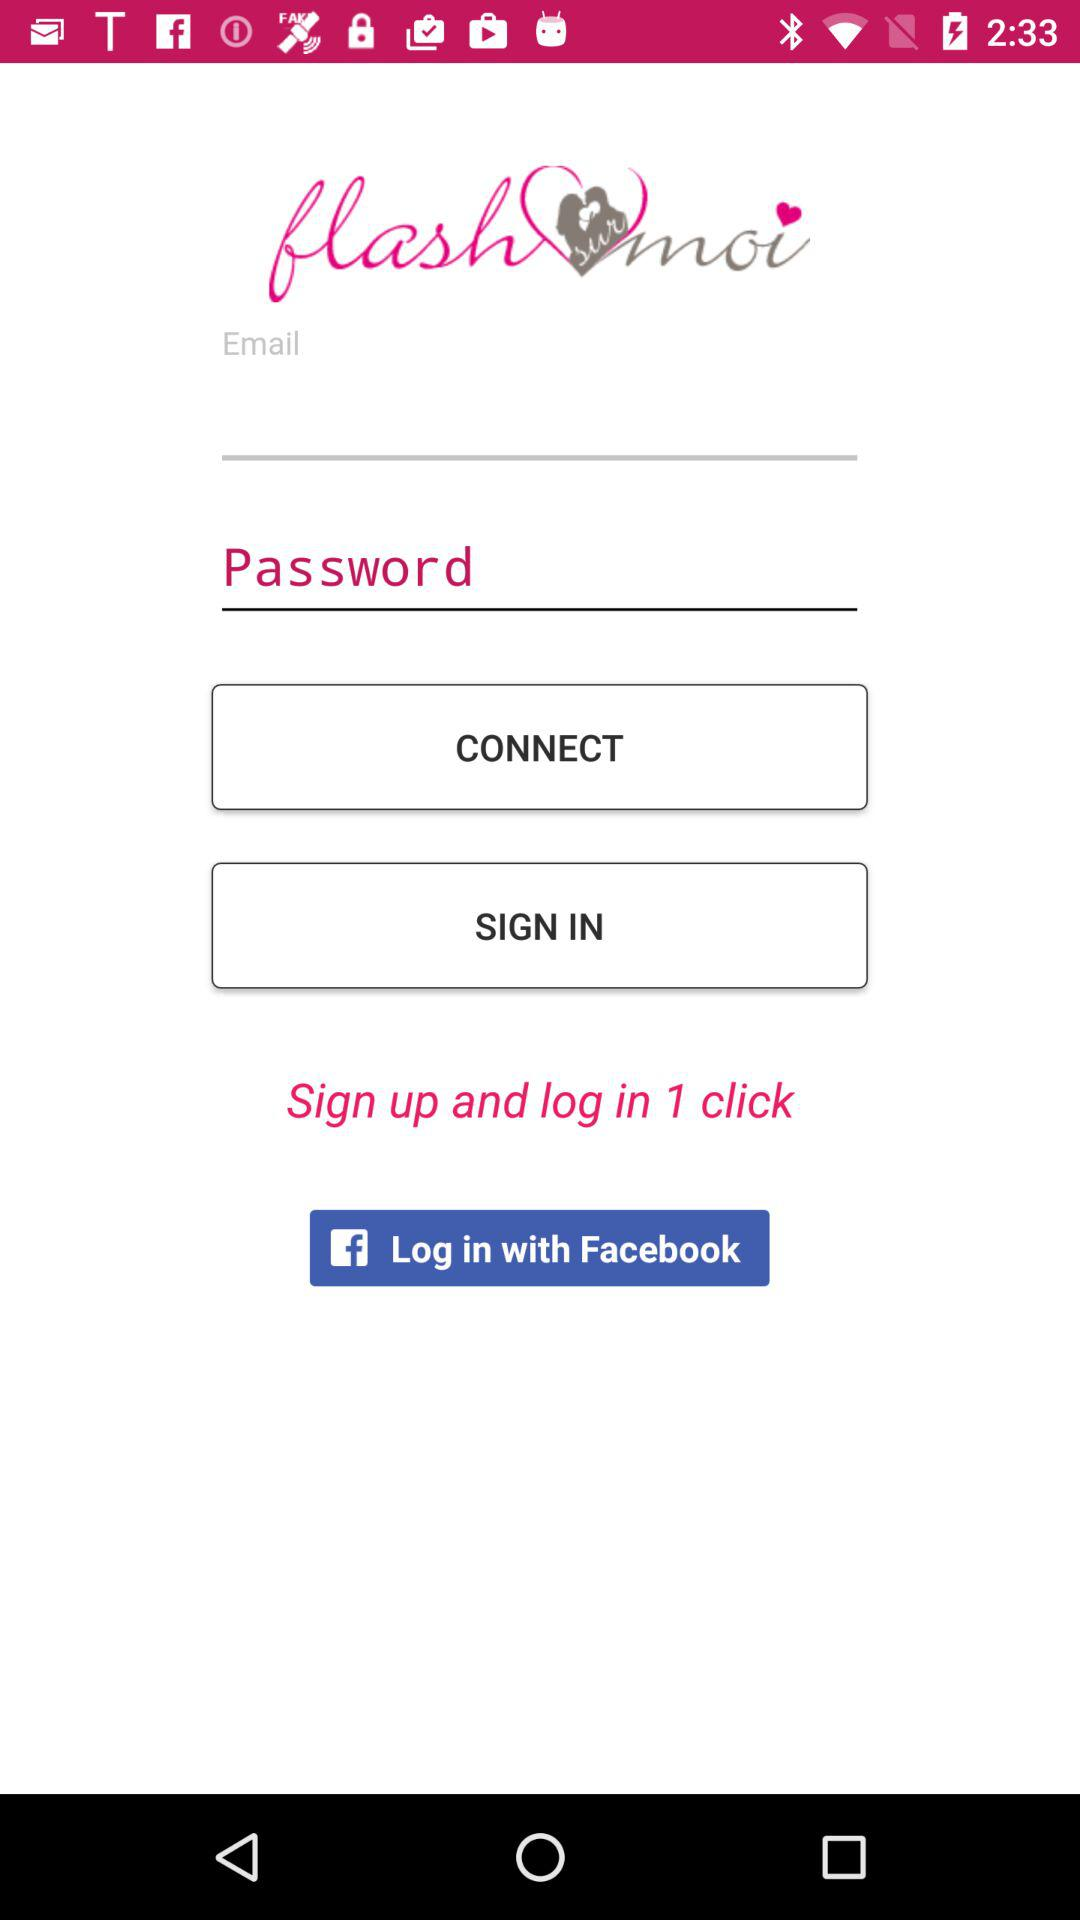What application can be used to log in? The application that can be used to log in is "Facebook". 